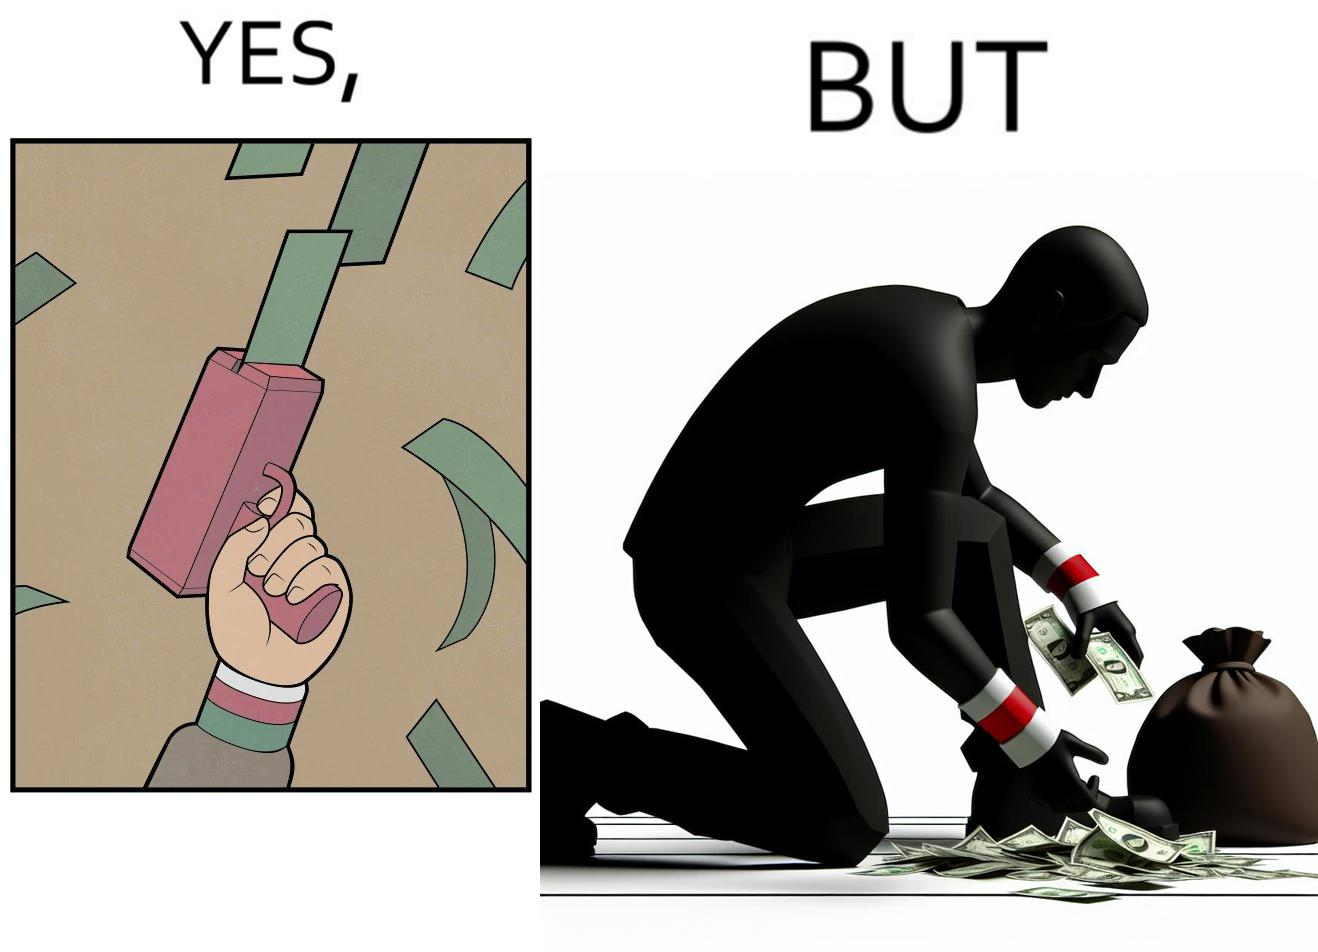Is this a satirical image? Yes, this image is satirical. 